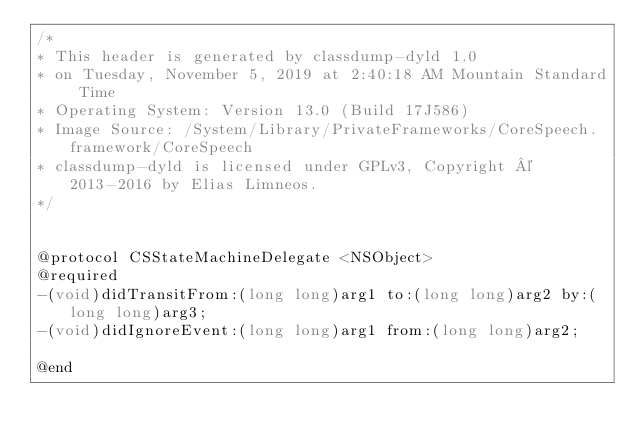<code> <loc_0><loc_0><loc_500><loc_500><_C_>/*
* This header is generated by classdump-dyld 1.0
* on Tuesday, November 5, 2019 at 2:40:18 AM Mountain Standard Time
* Operating System: Version 13.0 (Build 17J586)
* Image Source: /System/Library/PrivateFrameworks/CoreSpeech.framework/CoreSpeech
* classdump-dyld is licensed under GPLv3, Copyright © 2013-2016 by Elias Limneos.
*/


@protocol CSStateMachineDelegate <NSObject>
@required
-(void)didTransitFrom:(long long)arg1 to:(long long)arg2 by:(long long)arg3;
-(void)didIgnoreEvent:(long long)arg1 from:(long long)arg2;

@end

</code> 